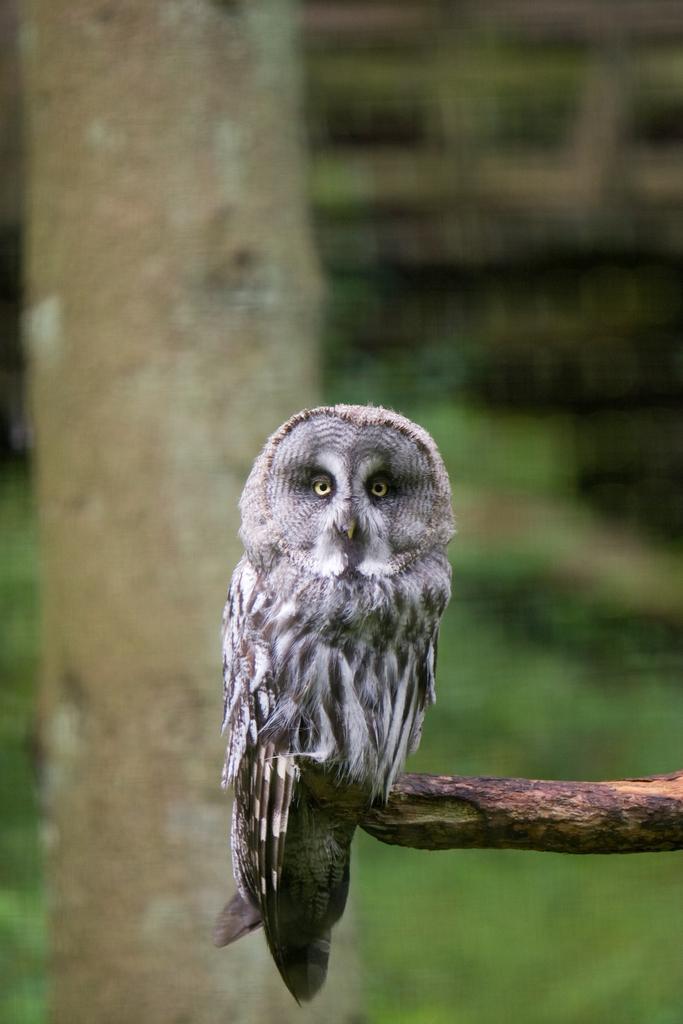Please provide a concise description of this image. In this picture there is an owl, standing on this wooden stick. On the bottom right we can see grass. On the left there is a tree. 